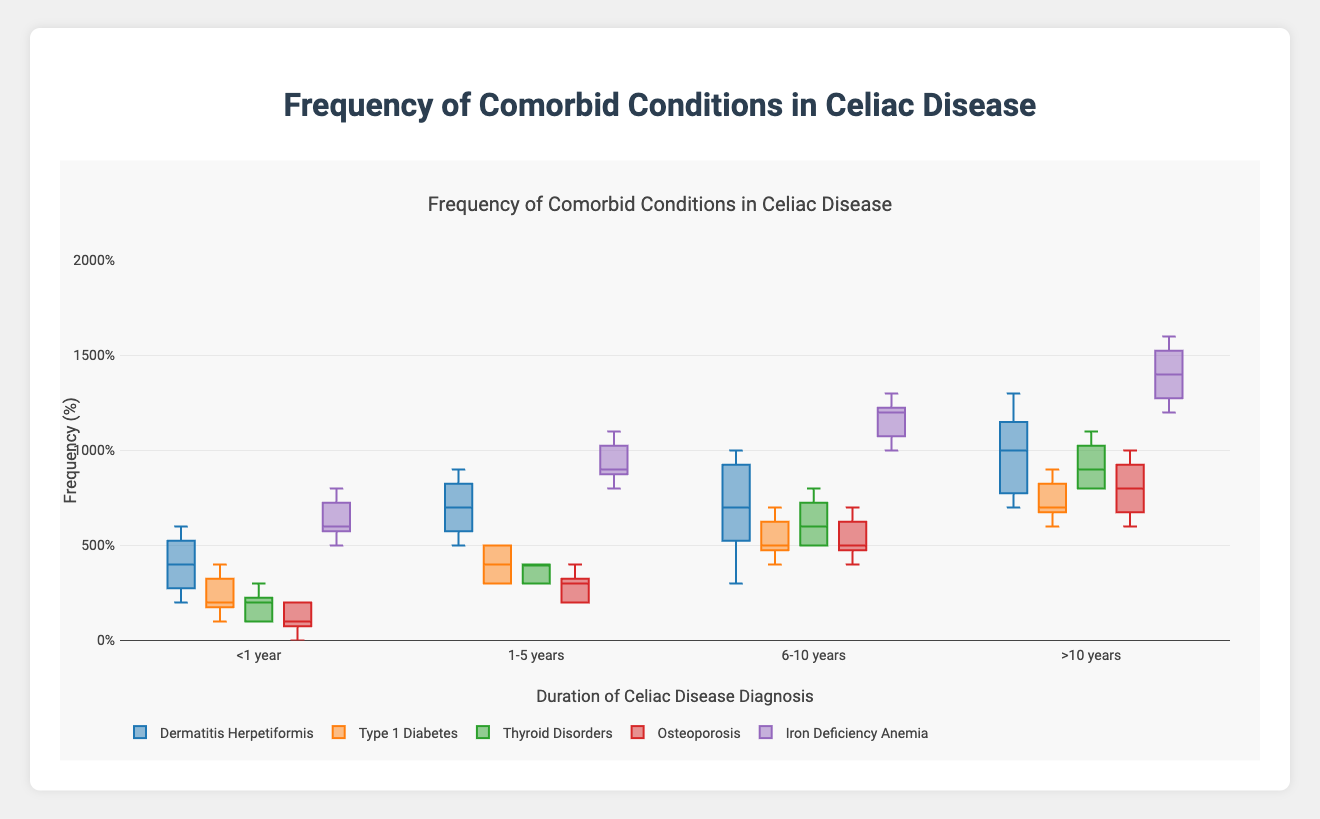What are the durations of celiac disease diagnosis covered in the plot? The x-axis labels indicate the durations of celiac disease diagnosis, which are "<1 year", "1-5 years", "6-10 years", and ">10 years". These represent the different time durations considered in the data.
Answer: "<1 year", "1-5 years", "6-10 years", ">10 years" Which comorbid condition has the highest median value for individuals diagnosed for more than 10 years? To find this, look at the median line (middle line inside the box) for all conditions under the category ">10 years". "Iron Deficiency Anemia" shows the highest median value among all the conditions.
Answer: Iron Deficiency Anemia How does the frequency of Type 1 Diabetes change with the duration of celiac disease diagnosis? Observe the box plots for "Type 1 Diabetes" across the different durations. The median values increase as the duration of diagnosis extends from "<1 year" to ">10 years".
Answer: Increases What is the range of frequencies for Dermatitis Herpetiformis in individuals diagnosed for 1-5 years? The range of a box plot is given by the distance between the minimum and maximum whiskers. For "Dermatitis Herpetiformis", in the "1-5 years" duration, it ranges from 5% to 9%.
Answer: 5% to 9% Which comorbid condition has the most consistent (least variable) frequency across all durations of diagnosis? The least variable data would have the smallest interquartile range (IQR) and smallest spread between whiskers. "Osteoporosis" appears to have boxes and whiskers that are relatively close across all durations of diagnosis, indicating the most consistent frequencies.
Answer: Osteoporosis For which duration of diagnosis does Iron Deficiency Anemia have the widest interquartile range (IQR)? The IQR is the range between the first quartile (Q1) and third quartile (Q3), highlighted by the height of the box. "Iron Deficiency Anemia" seems to have the widest IQR between "6-10 years" based on the size of the box.
Answer: 6-10 years Which duration of diagnosis shows the highest median frequency for Thyroid Disorders? Consider the median line inside the box for "Thyroid Disorders" across all durations. The highest median is in the ">10 years" category.
Answer: >10 years In the <1 year diagnosis duration, which comorbid condition has the lowest median frequency? Look at the median lines inside the boxes for all conditions in the "<1 year" category. "Osteoporosis" has the lowest median frequency here.
Answer: Osteoporosis 